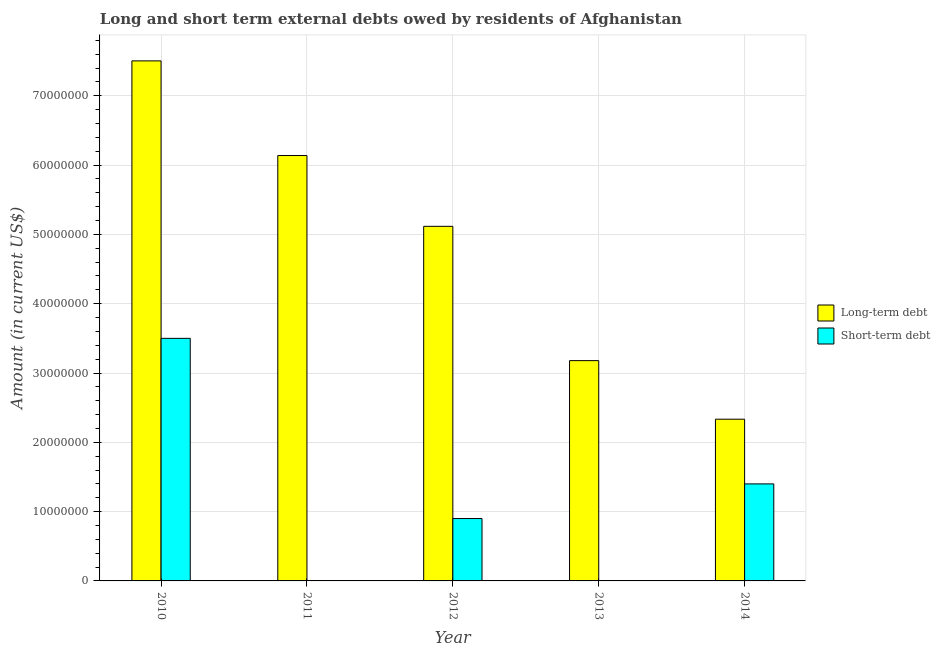Are the number of bars on each tick of the X-axis equal?
Your response must be concise. No. How many bars are there on the 3rd tick from the right?
Your answer should be compact. 2. What is the label of the 3rd group of bars from the left?
Make the answer very short. 2012. What is the long-term debts owed by residents in 2010?
Keep it short and to the point. 7.50e+07. Across all years, what is the maximum long-term debts owed by residents?
Provide a short and direct response. 7.50e+07. Across all years, what is the minimum long-term debts owed by residents?
Make the answer very short. 2.33e+07. In which year was the long-term debts owed by residents maximum?
Your answer should be very brief. 2010. What is the total long-term debts owed by residents in the graph?
Offer a very short reply. 2.43e+08. What is the difference between the short-term debts owed by residents in 2010 and that in 2014?
Keep it short and to the point. 2.10e+07. What is the difference between the long-term debts owed by residents in 2010 and the short-term debts owed by residents in 2013?
Give a very brief answer. 4.33e+07. What is the average long-term debts owed by residents per year?
Your response must be concise. 4.85e+07. In how many years, is the long-term debts owed by residents greater than 48000000 US$?
Give a very brief answer. 3. Is the long-term debts owed by residents in 2010 less than that in 2011?
Ensure brevity in your answer.  No. What is the difference between the highest and the second highest short-term debts owed by residents?
Give a very brief answer. 2.10e+07. What is the difference between the highest and the lowest short-term debts owed by residents?
Provide a short and direct response. 3.50e+07. In how many years, is the short-term debts owed by residents greater than the average short-term debts owed by residents taken over all years?
Offer a terse response. 2. How many bars are there?
Keep it short and to the point. 8. Are all the bars in the graph horizontal?
Provide a succinct answer. No. How many years are there in the graph?
Your answer should be compact. 5. What is the difference between two consecutive major ticks on the Y-axis?
Ensure brevity in your answer.  1.00e+07. Are the values on the major ticks of Y-axis written in scientific E-notation?
Provide a short and direct response. No. Does the graph contain any zero values?
Your answer should be compact. Yes. Does the graph contain grids?
Your answer should be compact. Yes. Where does the legend appear in the graph?
Offer a terse response. Center right. How many legend labels are there?
Make the answer very short. 2. How are the legend labels stacked?
Offer a terse response. Vertical. What is the title of the graph?
Provide a short and direct response. Long and short term external debts owed by residents of Afghanistan. Does "Number of departures" appear as one of the legend labels in the graph?
Offer a terse response. No. What is the label or title of the X-axis?
Ensure brevity in your answer.  Year. What is the label or title of the Y-axis?
Make the answer very short. Amount (in current US$). What is the Amount (in current US$) in Long-term debt in 2010?
Provide a short and direct response. 7.50e+07. What is the Amount (in current US$) in Short-term debt in 2010?
Your answer should be compact. 3.50e+07. What is the Amount (in current US$) in Long-term debt in 2011?
Make the answer very short. 6.14e+07. What is the Amount (in current US$) in Long-term debt in 2012?
Provide a succinct answer. 5.12e+07. What is the Amount (in current US$) in Short-term debt in 2012?
Offer a terse response. 9.00e+06. What is the Amount (in current US$) in Long-term debt in 2013?
Give a very brief answer. 3.18e+07. What is the Amount (in current US$) in Long-term debt in 2014?
Your response must be concise. 2.33e+07. What is the Amount (in current US$) in Short-term debt in 2014?
Give a very brief answer. 1.40e+07. Across all years, what is the maximum Amount (in current US$) of Long-term debt?
Ensure brevity in your answer.  7.50e+07. Across all years, what is the maximum Amount (in current US$) of Short-term debt?
Your answer should be compact. 3.50e+07. Across all years, what is the minimum Amount (in current US$) of Long-term debt?
Your response must be concise. 2.33e+07. What is the total Amount (in current US$) of Long-term debt in the graph?
Provide a succinct answer. 2.43e+08. What is the total Amount (in current US$) of Short-term debt in the graph?
Offer a very short reply. 5.80e+07. What is the difference between the Amount (in current US$) of Long-term debt in 2010 and that in 2011?
Give a very brief answer. 1.37e+07. What is the difference between the Amount (in current US$) in Long-term debt in 2010 and that in 2012?
Your answer should be very brief. 2.39e+07. What is the difference between the Amount (in current US$) of Short-term debt in 2010 and that in 2012?
Give a very brief answer. 2.60e+07. What is the difference between the Amount (in current US$) of Long-term debt in 2010 and that in 2013?
Keep it short and to the point. 4.33e+07. What is the difference between the Amount (in current US$) of Long-term debt in 2010 and that in 2014?
Provide a succinct answer. 5.17e+07. What is the difference between the Amount (in current US$) in Short-term debt in 2010 and that in 2014?
Offer a terse response. 2.10e+07. What is the difference between the Amount (in current US$) of Long-term debt in 2011 and that in 2012?
Your answer should be compact. 1.02e+07. What is the difference between the Amount (in current US$) of Long-term debt in 2011 and that in 2013?
Give a very brief answer. 2.96e+07. What is the difference between the Amount (in current US$) in Long-term debt in 2011 and that in 2014?
Provide a succinct answer. 3.80e+07. What is the difference between the Amount (in current US$) of Long-term debt in 2012 and that in 2013?
Keep it short and to the point. 1.94e+07. What is the difference between the Amount (in current US$) in Long-term debt in 2012 and that in 2014?
Keep it short and to the point. 2.78e+07. What is the difference between the Amount (in current US$) of Short-term debt in 2012 and that in 2014?
Keep it short and to the point. -5.00e+06. What is the difference between the Amount (in current US$) in Long-term debt in 2013 and that in 2014?
Provide a succinct answer. 8.45e+06. What is the difference between the Amount (in current US$) in Long-term debt in 2010 and the Amount (in current US$) in Short-term debt in 2012?
Give a very brief answer. 6.60e+07. What is the difference between the Amount (in current US$) of Long-term debt in 2010 and the Amount (in current US$) of Short-term debt in 2014?
Keep it short and to the point. 6.10e+07. What is the difference between the Amount (in current US$) of Long-term debt in 2011 and the Amount (in current US$) of Short-term debt in 2012?
Keep it short and to the point. 5.24e+07. What is the difference between the Amount (in current US$) of Long-term debt in 2011 and the Amount (in current US$) of Short-term debt in 2014?
Offer a very short reply. 4.74e+07. What is the difference between the Amount (in current US$) in Long-term debt in 2012 and the Amount (in current US$) in Short-term debt in 2014?
Offer a very short reply. 3.72e+07. What is the difference between the Amount (in current US$) of Long-term debt in 2013 and the Amount (in current US$) of Short-term debt in 2014?
Provide a succinct answer. 1.78e+07. What is the average Amount (in current US$) in Long-term debt per year?
Give a very brief answer. 4.85e+07. What is the average Amount (in current US$) of Short-term debt per year?
Your answer should be very brief. 1.16e+07. In the year 2010, what is the difference between the Amount (in current US$) of Long-term debt and Amount (in current US$) of Short-term debt?
Keep it short and to the point. 4.00e+07. In the year 2012, what is the difference between the Amount (in current US$) of Long-term debt and Amount (in current US$) of Short-term debt?
Your answer should be compact. 4.22e+07. In the year 2014, what is the difference between the Amount (in current US$) of Long-term debt and Amount (in current US$) of Short-term debt?
Your response must be concise. 9.34e+06. What is the ratio of the Amount (in current US$) in Long-term debt in 2010 to that in 2011?
Your answer should be compact. 1.22. What is the ratio of the Amount (in current US$) of Long-term debt in 2010 to that in 2012?
Your answer should be compact. 1.47. What is the ratio of the Amount (in current US$) in Short-term debt in 2010 to that in 2012?
Offer a terse response. 3.89. What is the ratio of the Amount (in current US$) of Long-term debt in 2010 to that in 2013?
Give a very brief answer. 2.36. What is the ratio of the Amount (in current US$) in Long-term debt in 2010 to that in 2014?
Ensure brevity in your answer.  3.22. What is the ratio of the Amount (in current US$) of Long-term debt in 2011 to that in 2012?
Offer a terse response. 1.2. What is the ratio of the Amount (in current US$) in Long-term debt in 2011 to that in 2013?
Keep it short and to the point. 1.93. What is the ratio of the Amount (in current US$) of Long-term debt in 2011 to that in 2014?
Provide a short and direct response. 2.63. What is the ratio of the Amount (in current US$) of Long-term debt in 2012 to that in 2013?
Offer a terse response. 1.61. What is the ratio of the Amount (in current US$) in Long-term debt in 2012 to that in 2014?
Ensure brevity in your answer.  2.19. What is the ratio of the Amount (in current US$) of Short-term debt in 2012 to that in 2014?
Make the answer very short. 0.64. What is the ratio of the Amount (in current US$) of Long-term debt in 2013 to that in 2014?
Your response must be concise. 1.36. What is the difference between the highest and the second highest Amount (in current US$) of Long-term debt?
Provide a short and direct response. 1.37e+07. What is the difference between the highest and the second highest Amount (in current US$) in Short-term debt?
Give a very brief answer. 2.10e+07. What is the difference between the highest and the lowest Amount (in current US$) in Long-term debt?
Give a very brief answer. 5.17e+07. What is the difference between the highest and the lowest Amount (in current US$) in Short-term debt?
Provide a succinct answer. 3.50e+07. 